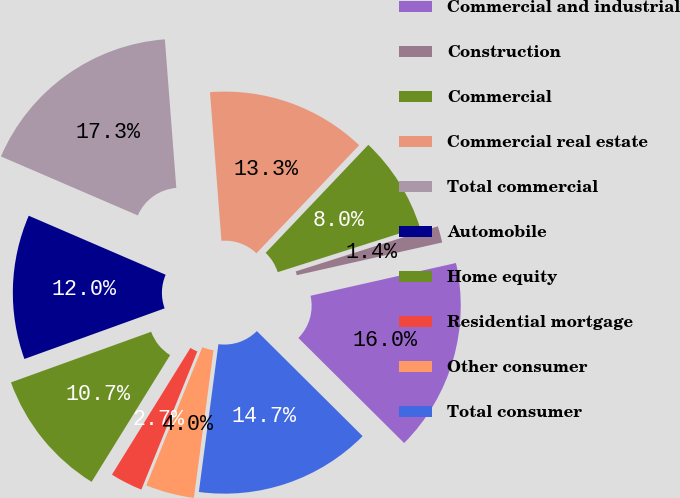Convert chart to OTSL. <chart><loc_0><loc_0><loc_500><loc_500><pie_chart><fcel>Commercial and industrial<fcel>Construction<fcel>Commercial<fcel>Commercial real estate<fcel>Total commercial<fcel>Automobile<fcel>Home equity<fcel>Residential mortgage<fcel>Other consumer<fcel>Total consumer<nl><fcel>15.97%<fcel>1.37%<fcel>8.01%<fcel>13.32%<fcel>17.3%<fcel>11.99%<fcel>10.66%<fcel>2.7%<fcel>4.03%<fcel>14.65%<nl></chart> 